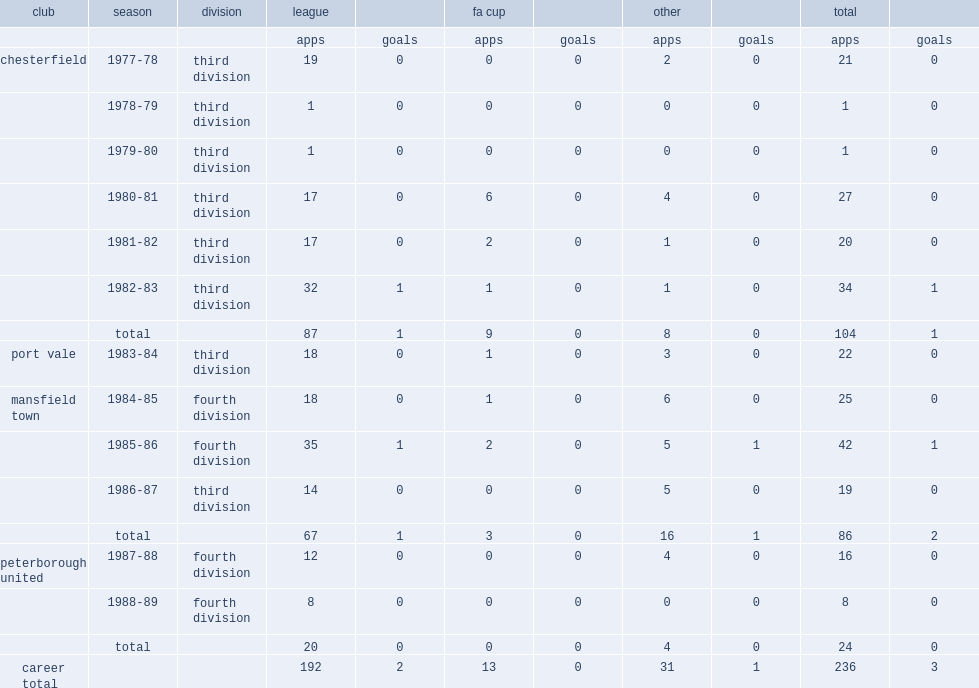How many goals did gary pollard score in league totally? 2.0. 